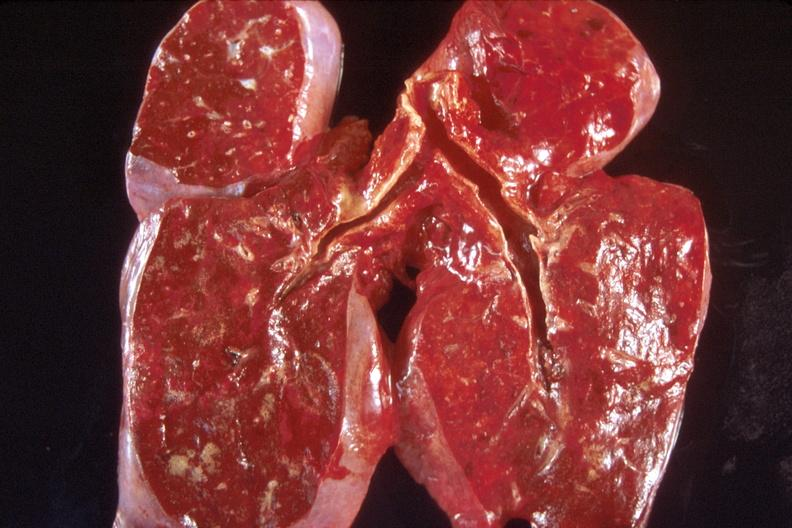does this image show lung, congestion?
Answer the question using a single word or phrase. Yes 